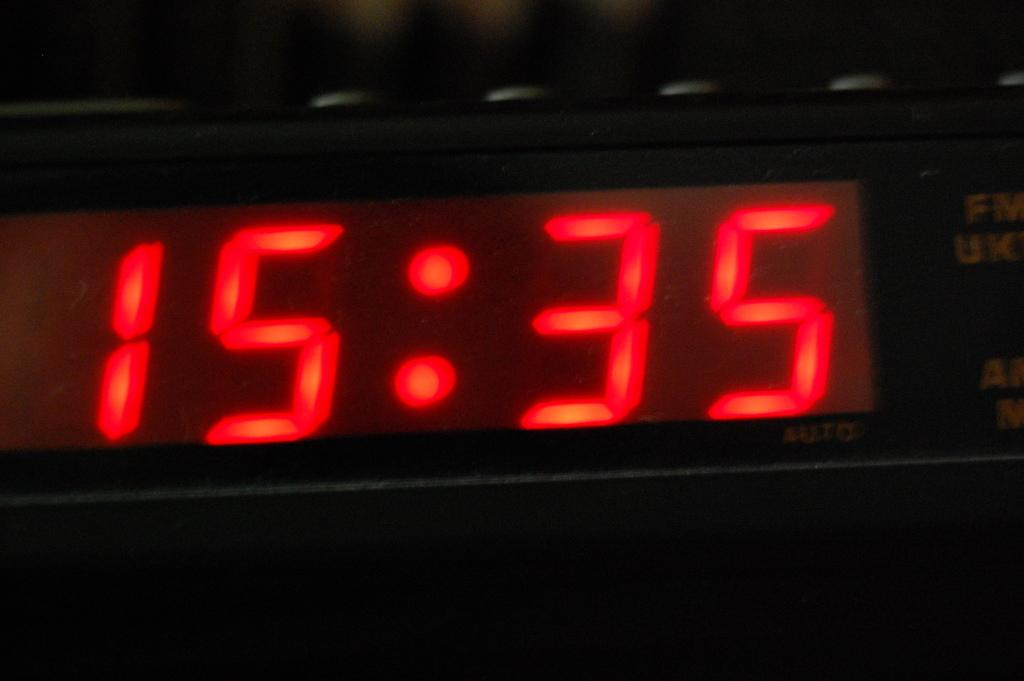<image>
Share a concise interpretation of the image provided. the alarm clock is saying that the time is 15:35 